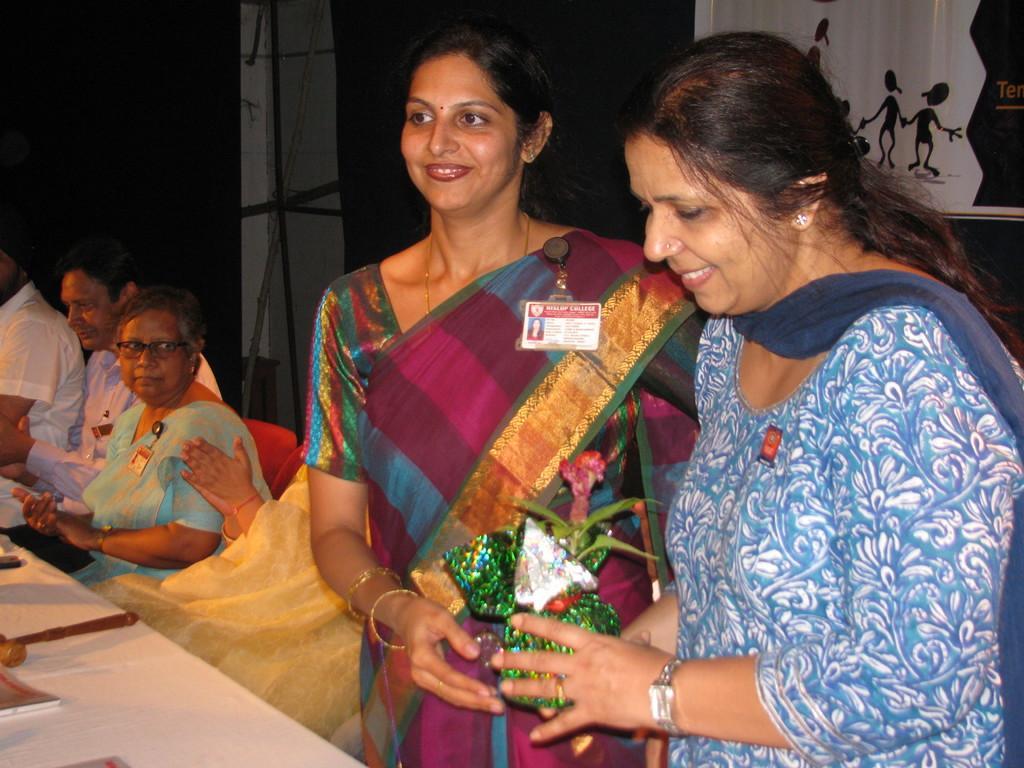How would you summarize this image in a sentence or two? In this image we can see two women are standing. One woman is wearing blue color dress and holding a gift in her hand. The other woman is wearing traditional dress and we can see ID on her shoulder. In the background, we can see bamboo pole, banner and black color curtains. There are people sitting on the left side of the image. We can see a table in the left bottom of the image. On the table, we can see few objects. 